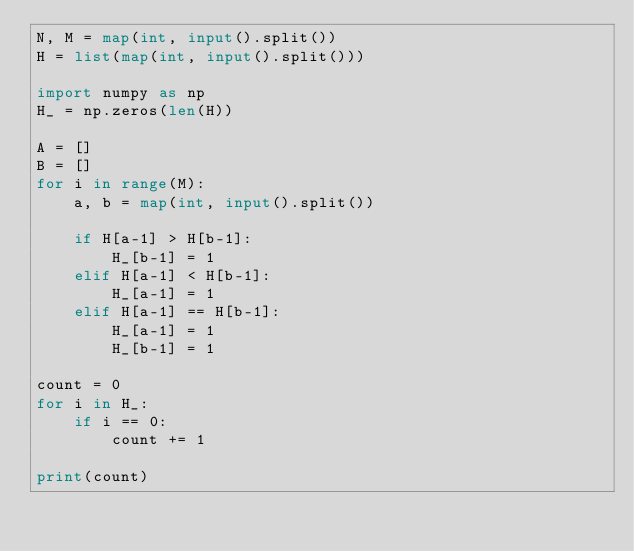Convert code to text. <code><loc_0><loc_0><loc_500><loc_500><_Python_>N, M = map(int, input().split())
H = list(map(int, input().split()))

import numpy as np
H_ = np.zeros(len(H))

A = []
B = []
for i in range(M):
    a, b = map(int, input().split())
    
    if H[a-1] > H[b-1]:
        H_[b-1] = 1
    elif H[a-1] < H[b-1]:
        H_[a-1] = 1
    elif H[a-1] == H[b-1]:
        H_[a-1] = 1
        H_[b-1] = 1
        
count = 0
for i in H_:
    if i == 0:
        count += 1
    
print(count)</code> 